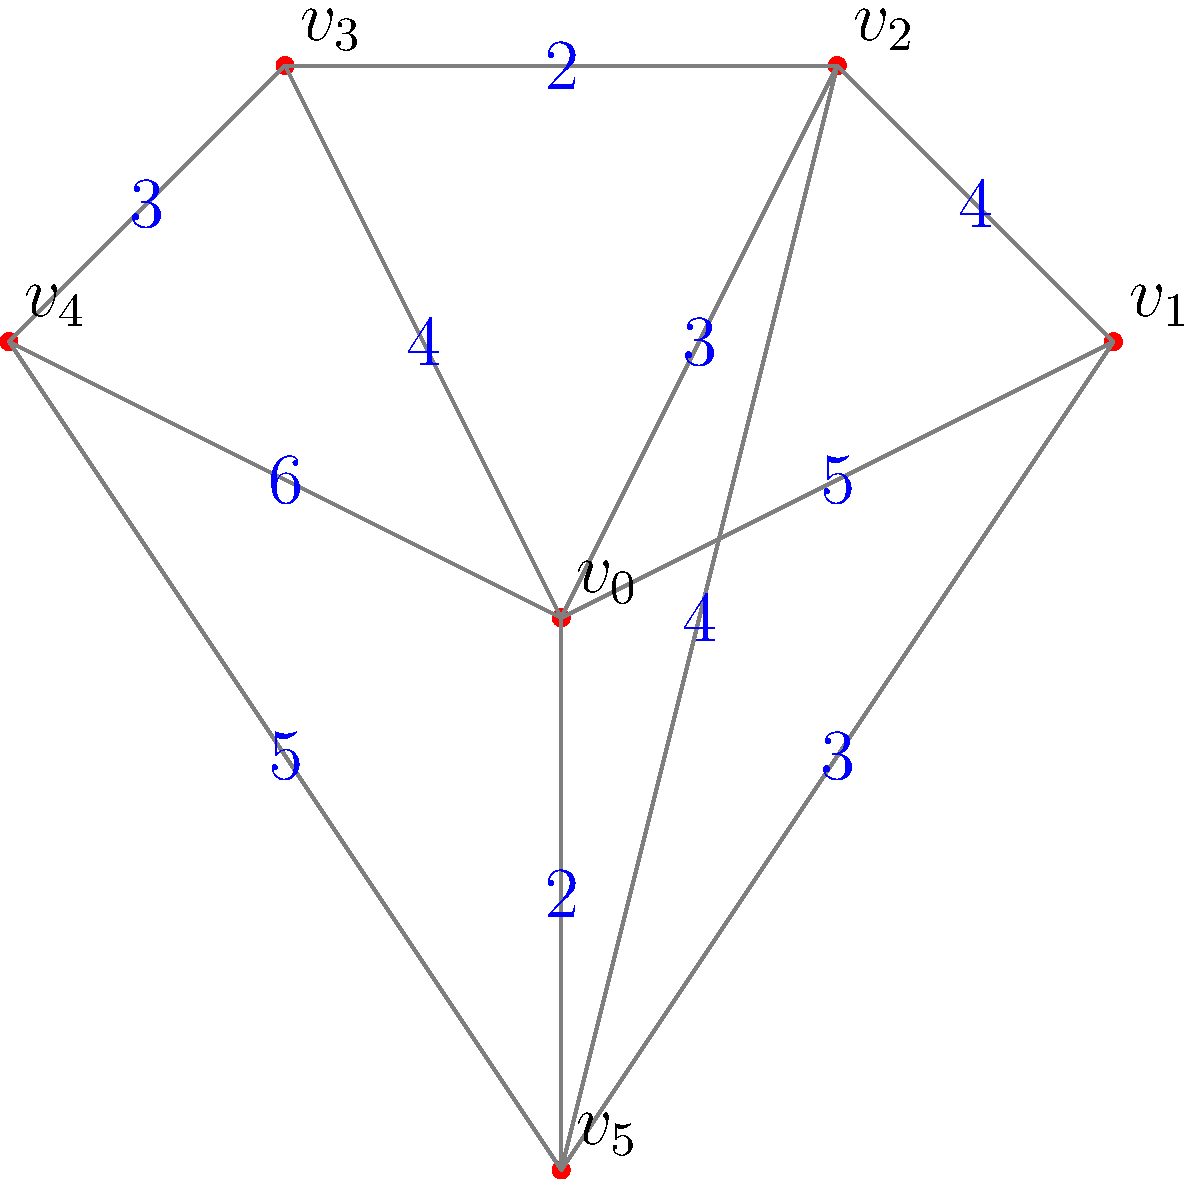A large corporate campus wants to connect various wellness amenities (represented by vertices $v_0$ to $v_5$) with walking paths. The distances between amenities are shown on the edges. What is the total length of the minimum spanning tree that connects all amenities? To find the minimum spanning tree (MST), we'll use Kruskal's algorithm:

1. Sort all edges by weight in ascending order:
   $(v_0, v_5, 2)$, $(v_2, v_3, 2)$, $(v_0, v_2, 3)$, $(v_1, v_5, 3)$, $(v_3, v_4, 3)$, $(v_0, v_3, 4)$, $(v_1, v_2, 4)$, $(v_2, v_5, 4)$, $(v_0, v_1, 5)$, $(v_4, v_5, 5)$, $(v_0, v_4, 6)$

2. Start with an empty MST and add edges that don't create cycles:
   - Add $(v_0, v_5, 2)$
   - Add $(v_2, v_3, 2)$
   - Add $(v_0, v_2, 3)$
   - Add $(v_1, v_5, 3)$
   - Add $(v_3, v_4, 3)$

3. The MST is complete with 5 edges (for 6 vertices).

4. Calculate the total length:
   $2 + 2 + 3 + 3 + 3 = 13$

Therefore, the total length of the minimum spanning tree is 13 units.
Answer: 13 units 